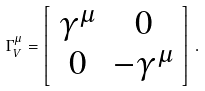Convert formula to latex. <formula><loc_0><loc_0><loc_500><loc_500>\Gamma ^ { \mu } _ { V } = \left [ \begin{array} { c c } \gamma ^ { \mu } & 0 \\ 0 & - \gamma ^ { \mu } \end{array} \right ] \, .</formula> 